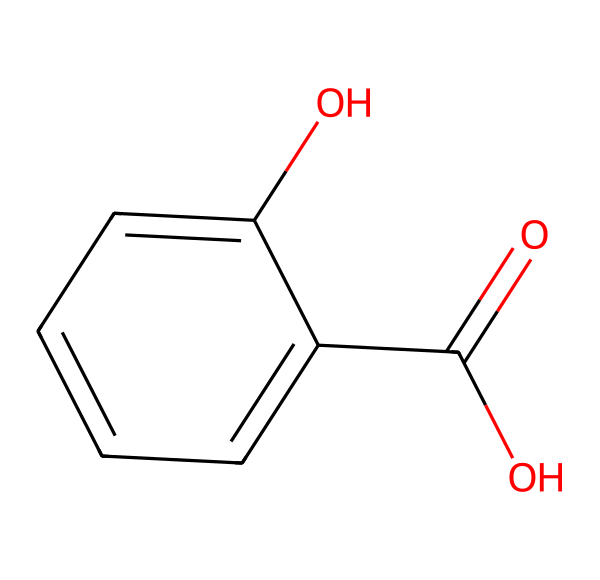What is the name of this chemical? The chemical structure presented is known as salicylic acid, which is indicated by the carboxylic acid and phenolic group in the structure.
Answer: salicylic acid How many carbon atoms are present in the structure? The structure contains seven carbon atoms which can be counted from the ring and the carboxylic group.
Answer: seven What functional groups are present in salicylic acid? The functional groups in salicylic acid include a carboxylic acid (–COOH) and a hydroxyl group (–OH) attached to the benzene ring, which are clearly visible in the structure.
Answer: carboxylic acid and hydroxyl What type of bond connects the carbon atoms in this chemical? The carbon atoms in salicylic acid are primarily connected by single covalent bonds, as indicated by the lack of double bonds between most carbon atoms in the cyclic part of the structure.
Answer: single covalent bonds What is the oxidation state of the hydroxyl group in salicylic acid? The hydroxyl group (–OH) has an oxidation state of -1, as the oxygen atom is more electronegative than hydrogen, creating a partial negative charge on oxygen.
Answer: -1 What is a primary use of salicylic acid in skincare? Salicylic acid is primarily used for its ability to exfoliate the skin and treat acne by penetrating into pores and preventing blockages.
Answer: acne treatment How does the presence of the hydroxyl group affect solubility? The hydroxyl group enhances the solubility of salicylic acid in water due to its ability to form hydrogen bonds with water molecules, increasing polarity.
Answer: increases solubility 